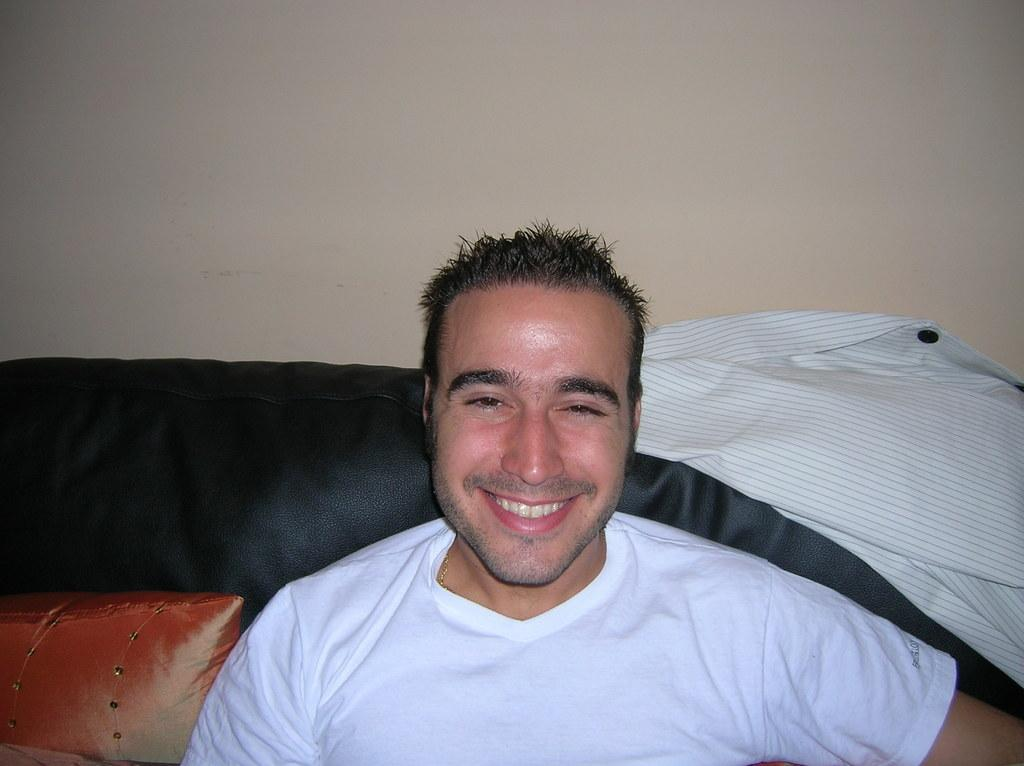Who is present in the image? There is a man in the image. What is the man wearing? The man is wearing a white t-shirt. What is the man doing in the image? The man is sitting on a sofa. What is the man's facial expression? The man has a smiling face. What can be seen on the right side of the image? There is a shirt in the right side of the image. What is visible in the background of the image? There is a wall in the background of the image. What type of crime is being committed in the image? There is no crime being committed in the image; it features a man sitting on a sofa with a smiling face. What kind of stone is visible in the image? There is no stone present in the image. 